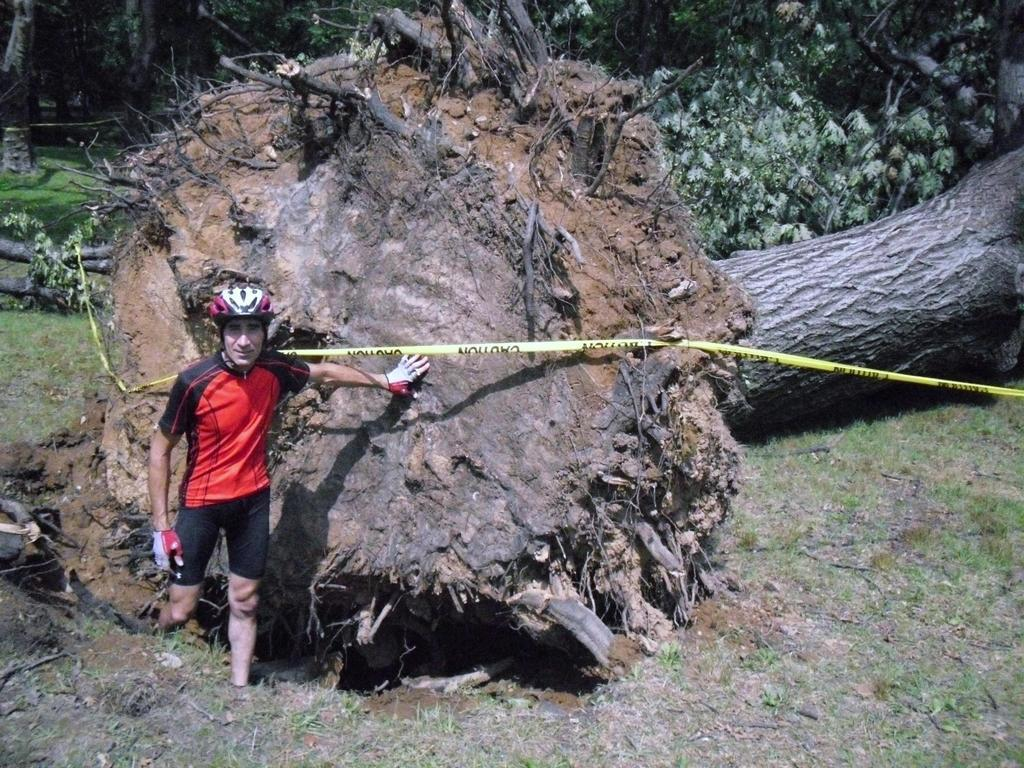What is located in the foreground of the image? There is a man standing in the foreground of the image, and there is also a tree on the ground. Can you describe the background of the image? In the background of the image, there are trees visible. What type of patch is sewn onto the man's shirt in the image? There is no patch visible on the man's shirt in the image. What type of locket is hanging from the tree in the image? There is no locket present in the image; it features a man and a tree in the foreground and trees in the background. 